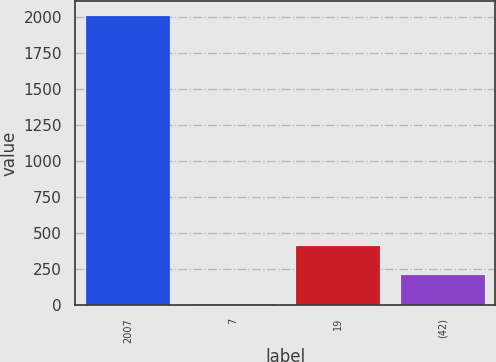<chart> <loc_0><loc_0><loc_500><loc_500><bar_chart><fcel>2007<fcel>7<fcel>19<fcel>(42)<nl><fcel>2006<fcel>6<fcel>406<fcel>206<nl></chart> 